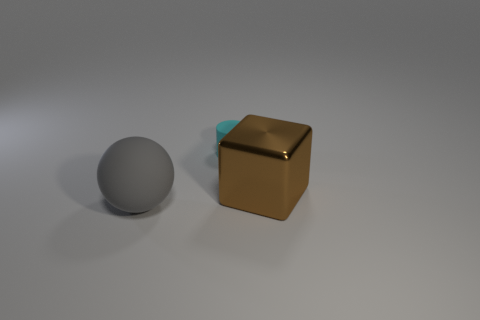Add 2 big gray matte things. How many objects exist? 5 Subtract all balls. How many objects are left? 2 Subtract all tiny rubber things. Subtract all big blue matte balls. How many objects are left? 2 Add 3 large gray matte objects. How many large gray matte objects are left? 4 Add 3 cyan rubber cylinders. How many cyan rubber cylinders exist? 4 Subtract 0 red cubes. How many objects are left? 3 Subtract all blue cylinders. Subtract all red balls. How many cylinders are left? 1 